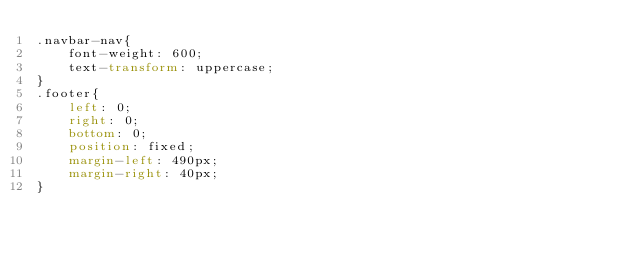Convert code to text. <code><loc_0><loc_0><loc_500><loc_500><_CSS_>.navbar-nav{
    font-weight: 600;
    text-transform: uppercase;
}
.footer{
    left: 0;
    right: 0;
    bottom: 0;
    position: fixed;
    margin-left: 490px;
    margin-right: 40px; 
}</code> 